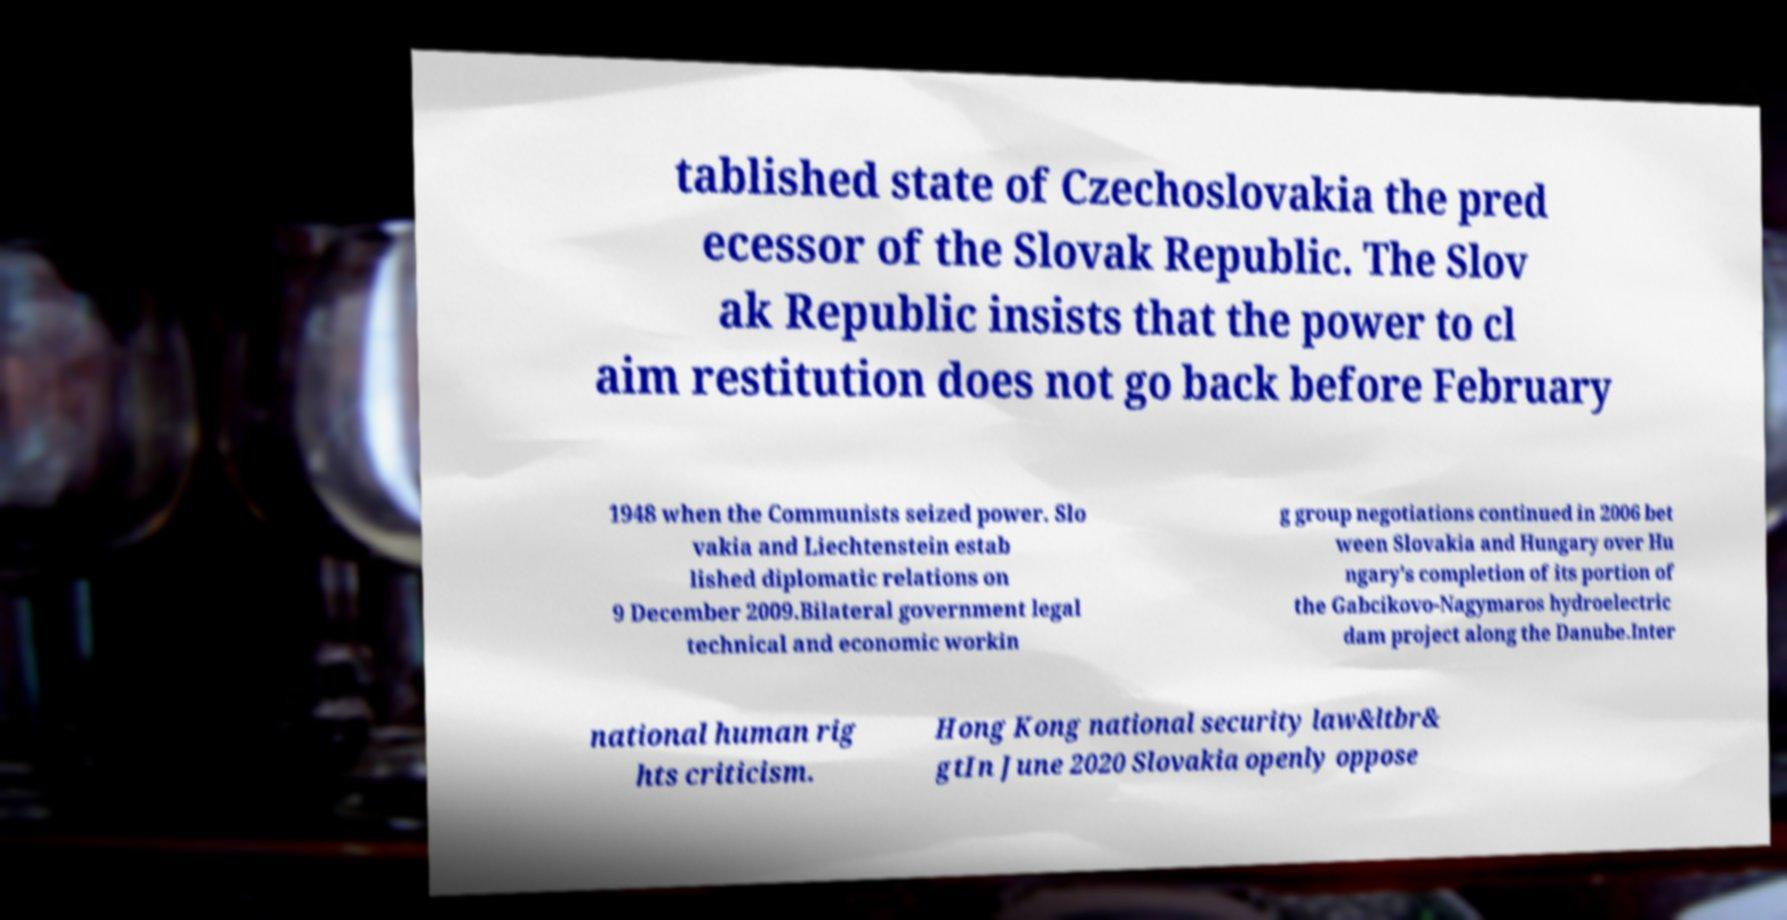Can you accurately transcribe the text from the provided image for me? tablished state of Czechoslovakia the pred ecessor of the Slovak Republic. The Slov ak Republic insists that the power to cl aim restitution does not go back before February 1948 when the Communists seized power. Slo vakia and Liechtenstein estab lished diplomatic relations on 9 December 2009.Bilateral government legal technical and economic workin g group negotiations continued in 2006 bet ween Slovakia and Hungary over Hu ngary's completion of its portion of the Gabcikovo-Nagymaros hydroelectric dam project along the Danube.Inter national human rig hts criticism. Hong Kong national security law&ltbr& gtIn June 2020 Slovakia openly oppose 